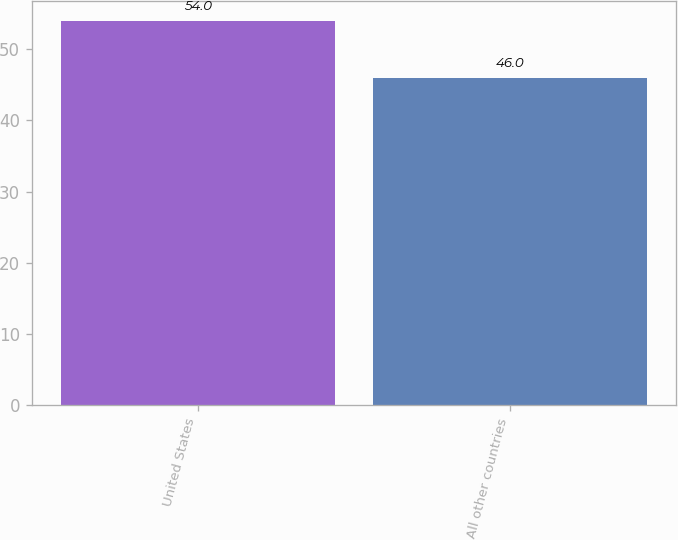Convert chart. <chart><loc_0><loc_0><loc_500><loc_500><bar_chart><fcel>United States<fcel>All other countries<nl><fcel>54<fcel>46<nl></chart> 